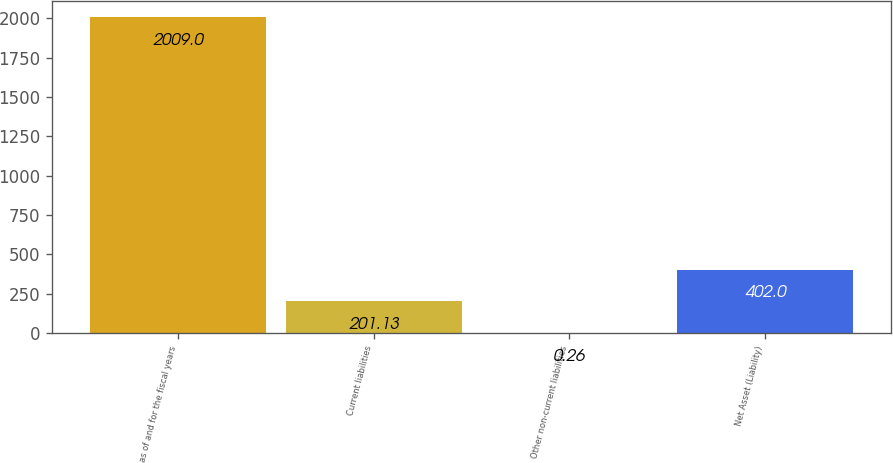Convert chart. <chart><loc_0><loc_0><loc_500><loc_500><bar_chart><fcel>as of and for the fiscal years<fcel>Current liabilities<fcel>Other non-current liabilities<fcel>Net Asset (Liability)<nl><fcel>2009<fcel>201.13<fcel>0.26<fcel>402<nl></chart> 